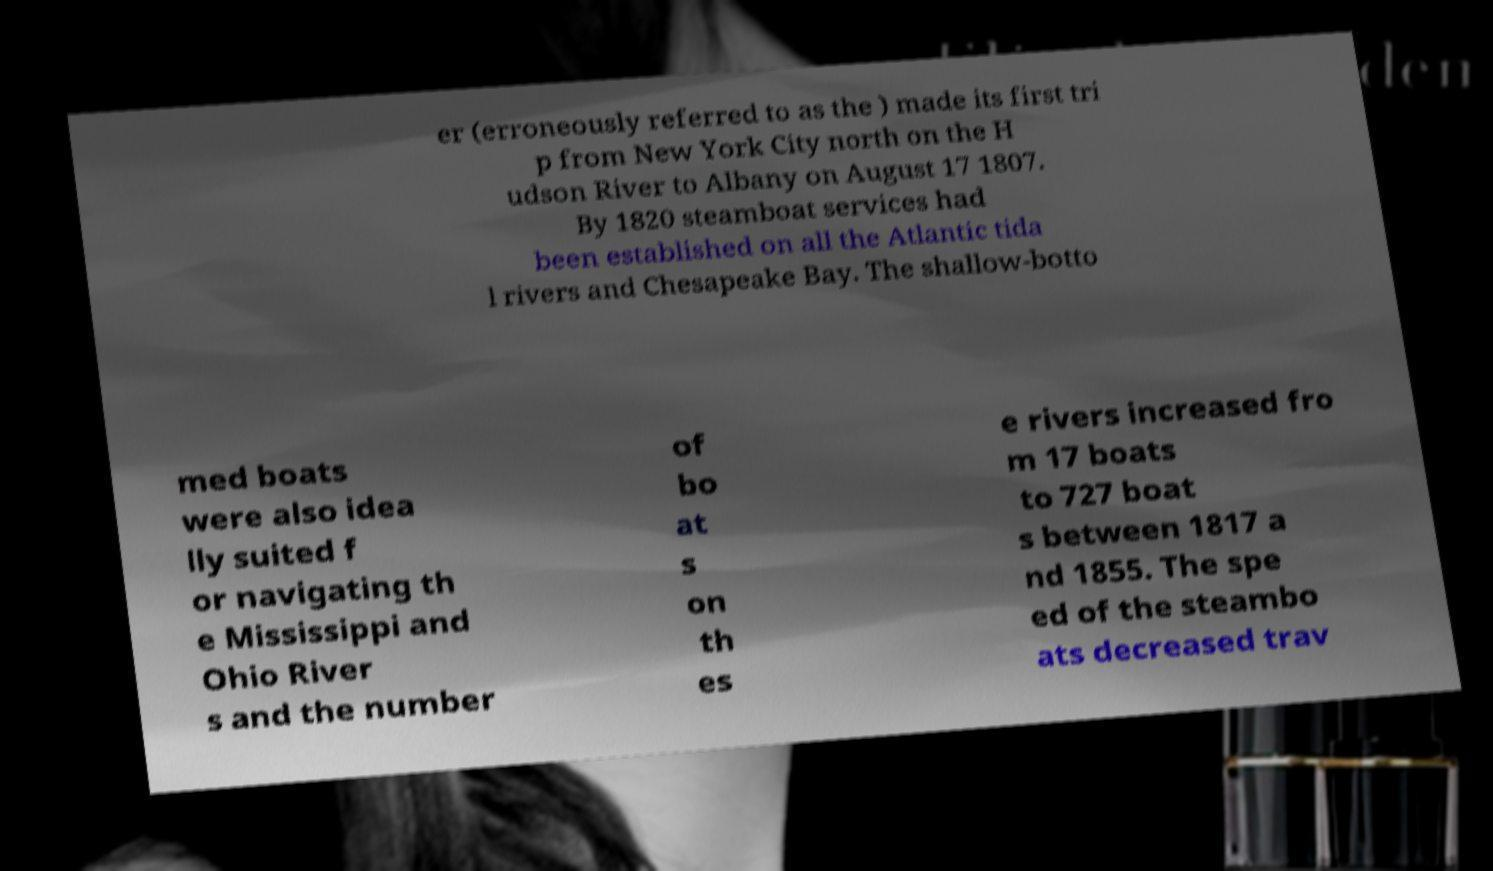I need the written content from this picture converted into text. Can you do that? er (erroneously referred to as the ) made its first tri p from New York City north on the H udson River to Albany on August 17 1807. By 1820 steamboat services had been established on all the Atlantic tida l rivers and Chesapeake Bay. The shallow-botto med boats were also idea lly suited f or navigating th e Mississippi and Ohio River s and the number of bo at s on th es e rivers increased fro m 17 boats to 727 boat s between 1817 a nd 1855. The spe ed of the steambo ats decreased trav 